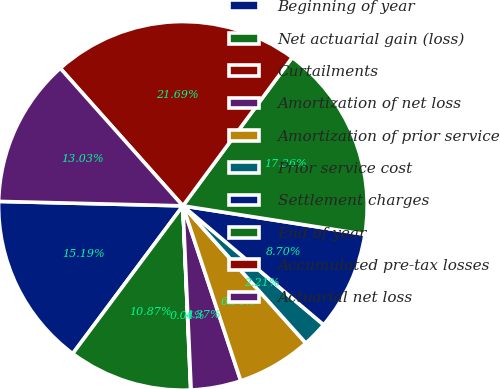<chart> <loc_0><loc_0><loc_500><loc_500><pie_chart><fcel>Beginning of year<fcel>Net actuarial gain (loss)<fcel>Curtailments<fcel>Amortization of net loss<fcel>Amortization of prior service<fcel>Prior service cost<fcel>Settlement charges<fcel>End of year<fcel>Accumulated pre-tax losses<fcel>Actuarial net loss<nl><fcel>15.19%<fcel>10.87%<fcel>0.04%<fcel>4.37%<fcel>6.54%<fcel>2.21%<fcel>8.7%<fcel>17.36%<fcel>21.69%<fcel>13.03%<nl></chart> 